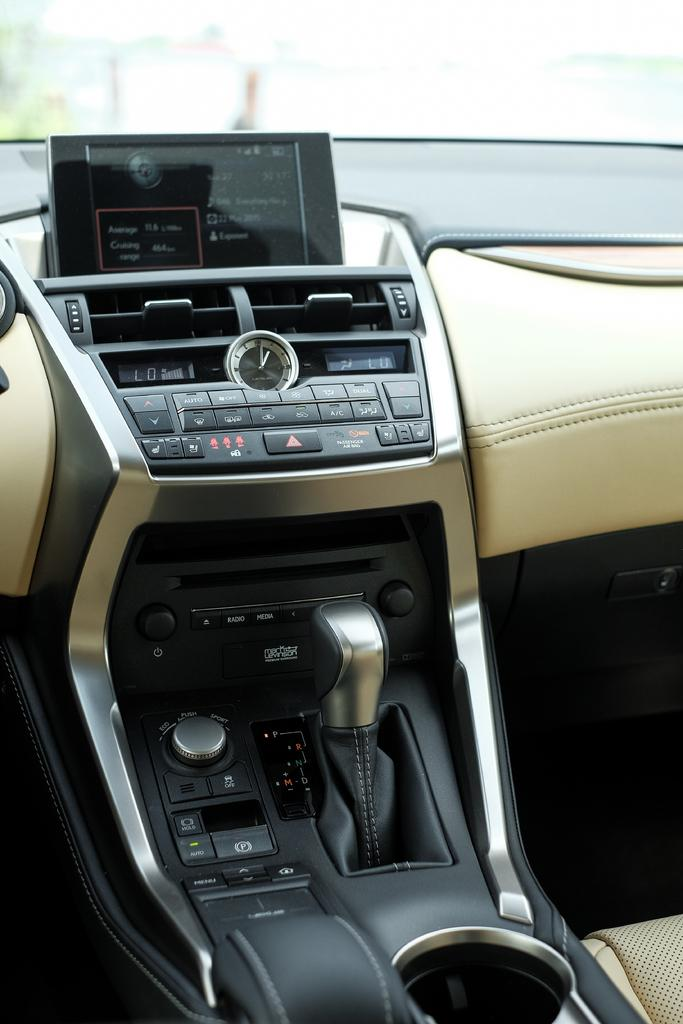Where was the image taken? The image is taken inside a car. What can be seen in the middle of the image? There is a gear in the middle of the image. What is visible in the background of the image? There is a glass window in the background of the image. Can you tell me which direction the father is facing in the image? There is no father present in the image, so it is not possible to determine the direction they might be facing. 